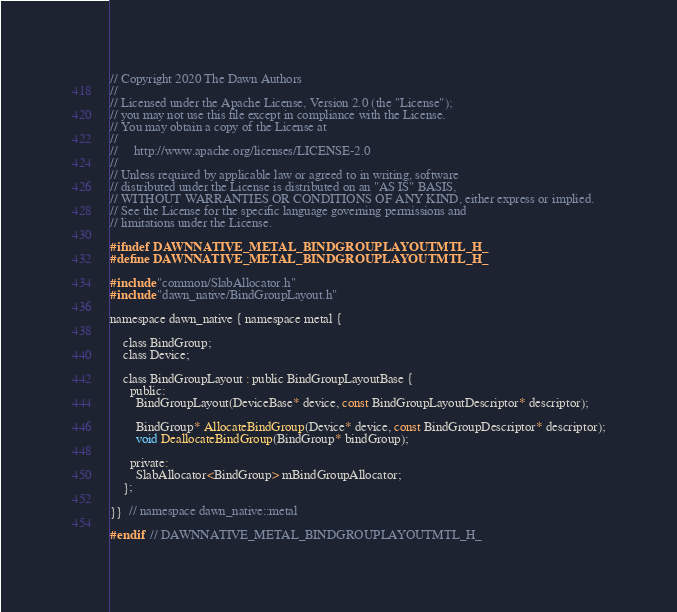Convert code to text. <code><loc_0><loc_0><loc_500><loc_500><_C_>// Copyright 2020 The Dawn Authors
//
// Licensed under the Apache License, Version 2.0 (the "License");
// you may not use this file except in compliance with the License.
// You may obtain a copy of the License at
//
//     http://www.apache.org/licenses/LICENSE-2.0
//
// Unless required by applicable law or agreed to in writing, software
// distributed under the License is distributed on an "AS IS" BASIS,
// WITHOUT WARRANTIES OR CONDITIONS OF ANY KIND, either express or implied.
// See the License for the specific language governing permissions and
// limitations under the License.

#ifndef DAWNNATIVE_METAL_BINDGROUPLAYOUTMTL_H_
#define DAWNNATIVE_METAL_BINDGROUPLAYOUTMTL_H_

#include "common/SlabAllocator.h"
#include "dawn_native/BindGroupLayout.h"

namespace dawn_native { namespace metal {

    class BindGroup;
    class Device;

    class BindGroupLayout : public BindGroupLayoutBase {
      public:
        BindGroupLayout(DeviceBase* device, const BindGroupLayoutDescriptor* descriptor);

        BindGroup* AllocateBindGroup(Device* device, const BindGroupDescriptor* descriptor);
        void DeallocateBindGroup(BindGroup* bindGroup);

      private:
        SlabAllocator<BindGroup> mBindGroupAllocator;
    };

}}  // namespace dawn_native::metal

#endif  // DAWNNATIVE_METAL_BINDGROUPLAYOUTMTL_H_
</code> 